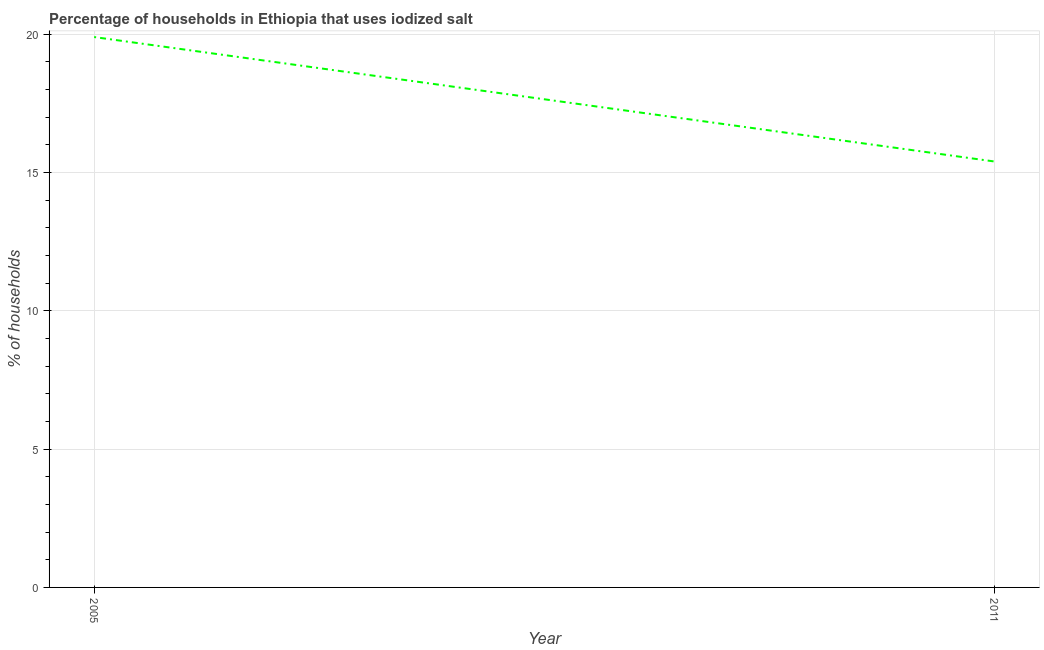Across all years, what is the maximum percentage of households where iodized salt is consumed?
Provide a succinct answer. 19.9. What is the sum of the percentage of households where iodized salt is consumed?
Keep it short and to the point. 35.3. What is the difference between the percentage of households where iodized salt is consumed in 2005 and 2011?
Ensure brevity in your answer.  4.5. What is the average percentage of households where iodized salt is consumed per year?
Your response must be concise. 17.65. What is the median percentage of households where iodized salt is consumed?
Your answer should be compact. 17.65. Do a majority of the years between 2011 and 2005 (inclusive) have percentage of households where iodized salt is consumed greater than 10 %?
Provide a short and direct response. No. What is the ratio of the percentage of households where iodized salt is consumed in 2005 to that in 2011?
Make the answer very short. 1.29. In how many years, is the percentage of households where iodized salt is consumed greater than the average percentage of households where iodized salt is consumed taken over all years?
Your answer should be very brief. 1. Does the percentage of households where iodized salt is consumed monotonically increase over the years?
Keep it short and to the point. No. Does the graph contain any zero values?
Keep it short and to the point. No. What is the title of the graph?
Ensure brevity in your answer.  Percentage of households in Ethiopia that uses iodized salt. What is the label or title of the X-axis?
Make the answer very short. Year. What is the label or title of the Y-axis?
Offer a terse response. % of households. What is the % of households of 2005?
Give a very brief answer. 19.9. What is the % of households in 2011?
Provide a short and direct response. 15.4. What is the ratio of the % of households in 2005 to that in 2011?
Ensure brevity in your answer.  1.29. 